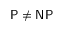<formula> <loc_0><loc_0><loc_500><loc_500>{ P } \neq { N P }</formula> 